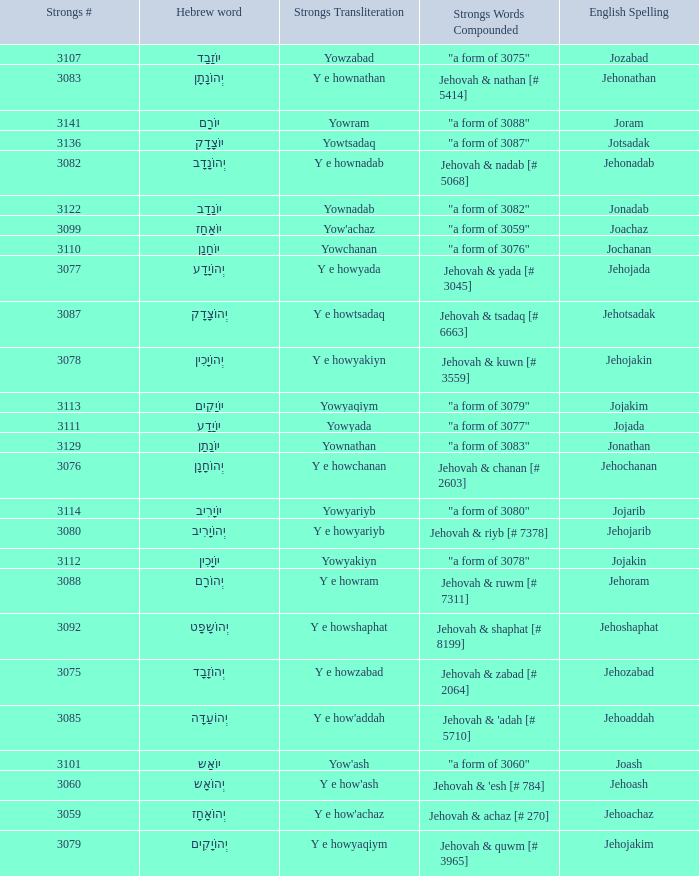Would you be able to parse every entry in this table? {'header': ['Strongs #', 'Hebrew word', 'Strongs Transliteration', 'Strongs Words Compounded', 'English Spelling'], 'rows': [['3107', 'יוֹזָבָד', 'Yowzabad', '"a form of 3075"', 'Jozabad'], ['3083', 'יְהוֹנָתָן', 'Y e hownathan', 'Jehovah & nathan [# 5414]', 'Jehonathan'], ['3141', 'יוֹרָם', 'Yowram', '"a form of 3088"', 'Joram'], ['3136', 'יוֹצָדָק', 'Yowtsadaq', '"a form of 3087"', 'Jotsadak'], ['3082', 'יְהוֹנָדָב', 'Y e hownadab', 'Jehovah & nadab [# 5068]', 'Jehonadab'], ['3122', 'יוֹנָדָב', 'Yownadab', '"a form of 3082"', 'Jonadab'], ['3099', 'יוֹאָחָז', "Yow'achaz", '"a form of 3059"', 'Joachaz'], ['3110', 'יוֹחָנָן', 'Yowchanan', '"a form of 3076"', 'Jochanan'], ['3077', 'יְהוֹיָדָע', 'Y e howyada', 'Jehovah & yada [# 3045]', 'Jehojada'], ['3087', 'יְהוֹצָדָק', 'Y e howtsadaq', 'Jehovah & tsadaq [# 6663]', 'Jehotsadak'], ['3078', 'יְהוֹיָכִין', 'Y e howyakiyn', 'Jehovah & kuwn [# 3559]', 'Jehojakin'], ['3113', 'יוֹיָקִים', 'Yowyaqiym', '"a form of 3079"', 'Jojakim'], ['3111', 'יוֹיָדָע', 'Yowyada', '"a form of 3077"', 'Jojada'], ['3129', 'יוֹנָתָן', 'Yownathan', '"a form of 3083"', 'Jonathan'], ['3076', 'יְהוֹחָנָן', 'Y e howchanan', 'Jehovah & chanan [# 2603]', 'Jehochanan'], ['3114', 'יוֹיָרִיב', 'Yowyariyb', '"a form of 3080"', 'Jojarib'], ['3080', 'יְהוֹיָרִיב', 'Y e howyariyb', 'Jehovah & riyb [# 7378]', 'Jehojarib'], ['3112', 'יוֹיָכִין', 'Yowyakiyn', '"a form of 3078"', 'Jojakin'], ['3088', 'יְהוֹרָם', 'Y e howram', 'Jehovah & ruwm [# 7311]', 'Jehoram'], ['3092', 'יְהוֹשָפָט', 'Y e howshaphat', 'Jehovah & shaphat [# 8199]', 'Jehoshaphat'], ['3075', 'יְהוֹזָבָד', 'Y e howzabad', 'Jehovah & zabad [# 2064]', 'Jehozabad'], ['3085', 'יְהוֹעַדָּה', "Y e how'addah", "Jehovah & 'adah [# 5710]", 'Jehoaddah'], ['3101', 'יוֹאָש', "Yow'ash", '"a form of 3060"', 'Joash'], ['3060', 'יְהוֹאָש', "Y e how'ash", "Jehovah & 'esh [# 784]", 'Jehoash'], ['3059', 'יְהוֹאָחָז', "Y e how'achaz", 'Jehovah & achaz [# 270]', 'Jehoachaz'], ['3079', 'יְהוֹיָקִים', 'Y e howyaqiym', 'Jehovah & quwm [# 3965]', 'Jehojakim']]} What is the strong words compounded when the strongs transliteration is yowyariyb? "a form of 3080". 